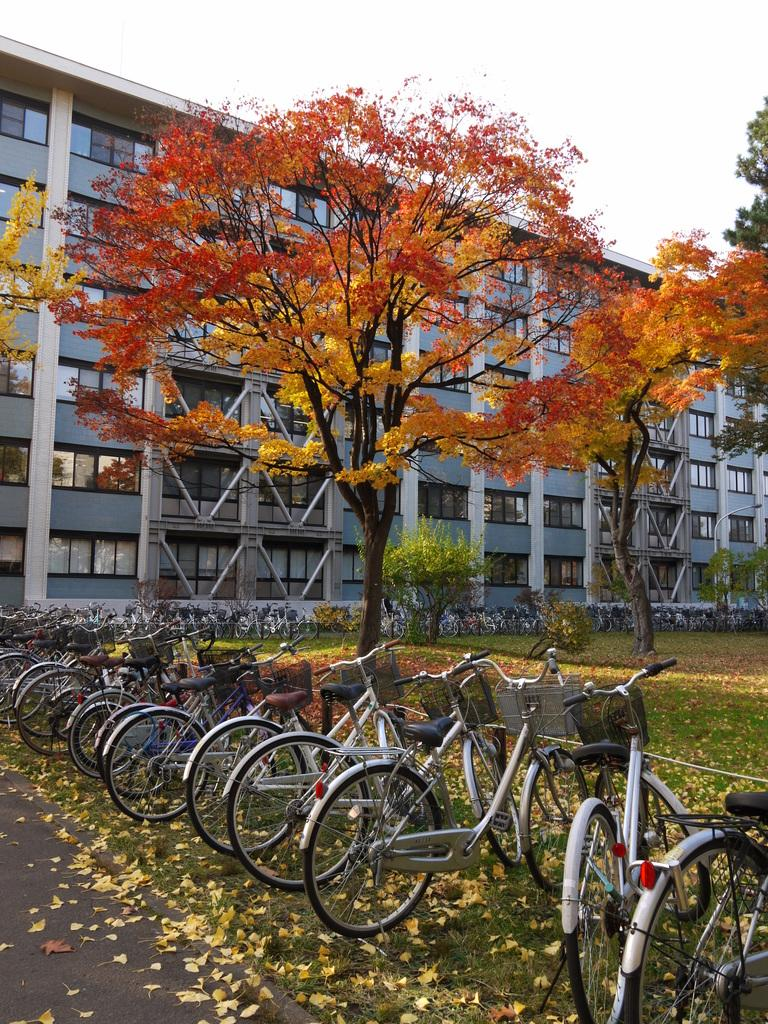What type of vehicles can be seen in the image? There are bicycles in the image. What type of natural elements are present in the image? There are trees in the image. What type of man-made structure is visible in the image? There is a building in the image. What is the ground like in the image? The ground is visible in the image, with grass and dried leaves. What part of the natural environment is visible in the image? The sky is visible in the image. What type of floor can be seen in the image? There is no floor present in the image; it is an outdoor scene with ground, trees, and a building. Is there a plane flying in the sky in the image? No, there is no plane visible in the image; only bicycles, trees, a building, and the sky are present. 